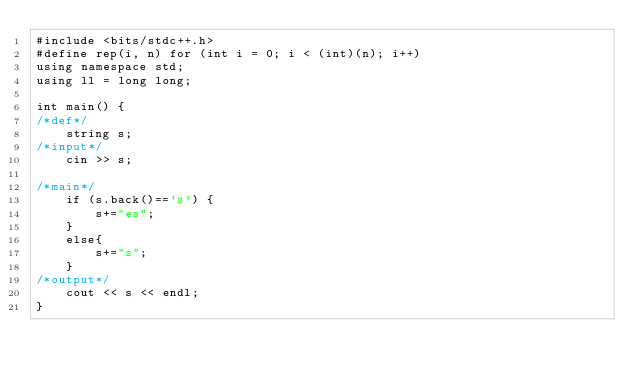Convert code to text. <code><loc_0><loc_0><loc_500><loc_500><_C++_>#include <bits/stdc++.h>
#define rep(i, n) for (int i = 0; i < (int)(n); i++)
using namespace std;
using ll = long long;

int main() {
/*def*/
    string s;
/*input*/
    cin >> s;

/*main*/
    if (s.back()=='s') {
        s+="es";
    }
    else{
        s+="s";
    }
/*output*/
    cout << s << endl;
}
</code> 